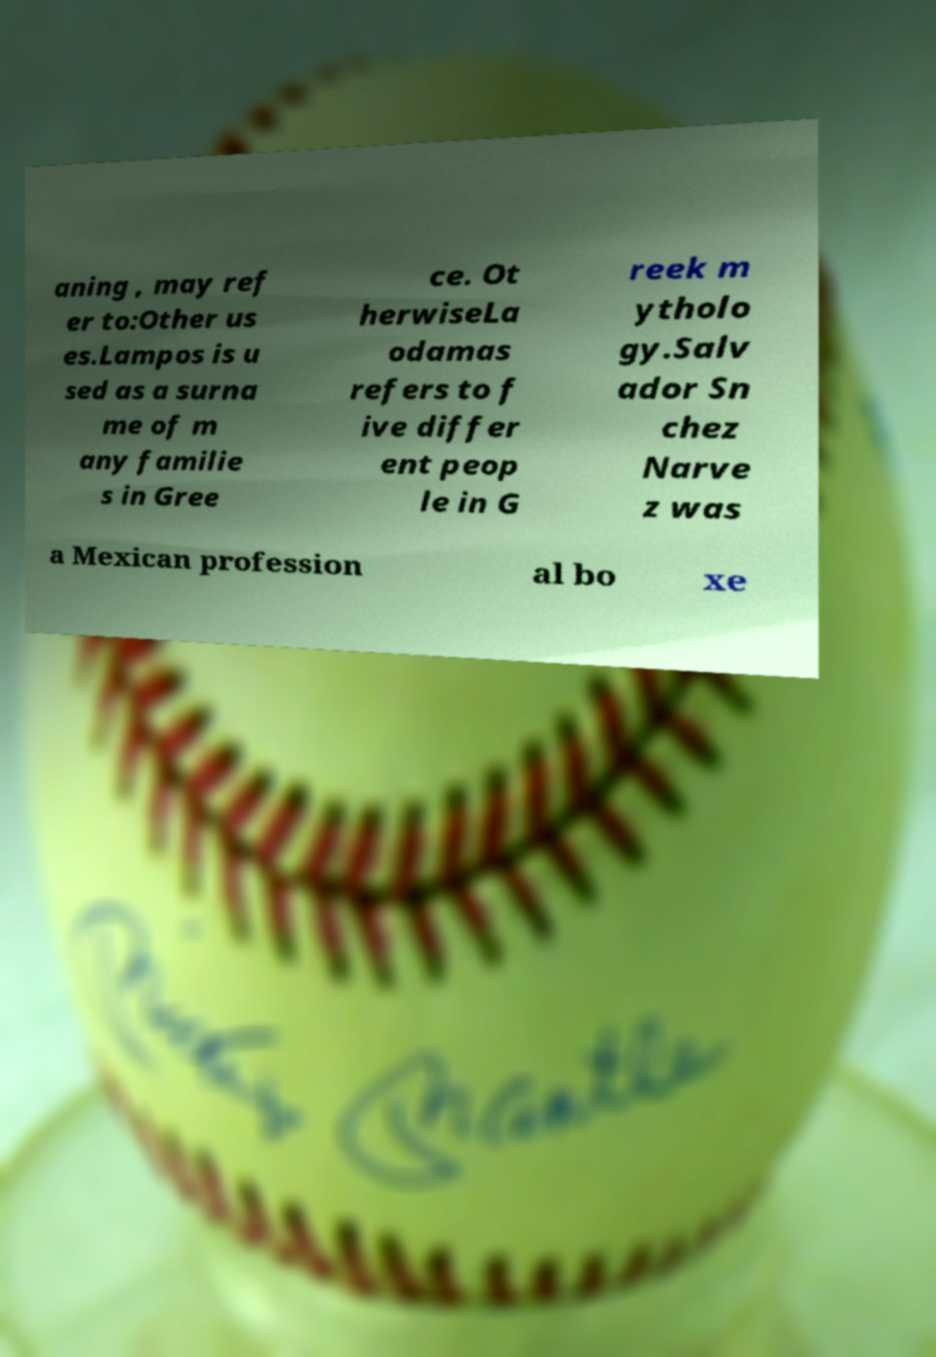Please read and relay the text visible in this image. What does it say? aning , may ref er to:Other us es.Lampos is u sed as a surna me of m any familie s in Gree ce. Ot herwiseLa odamas refers to f ive differ ent peop le in G reek m ytholo gy.Salv ador Sn chez Narve z was a Mexican profession al bo xe 